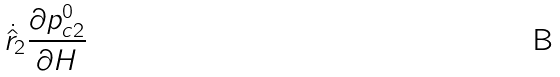Convert formula to latex. <formula><loc_0><loc_0><loc_500><loc_500>\dot { \hat { r } } _ { 2 } \frac { \partial p ^ { 0 } _ { c 2 } } { \partial H }</formula> 